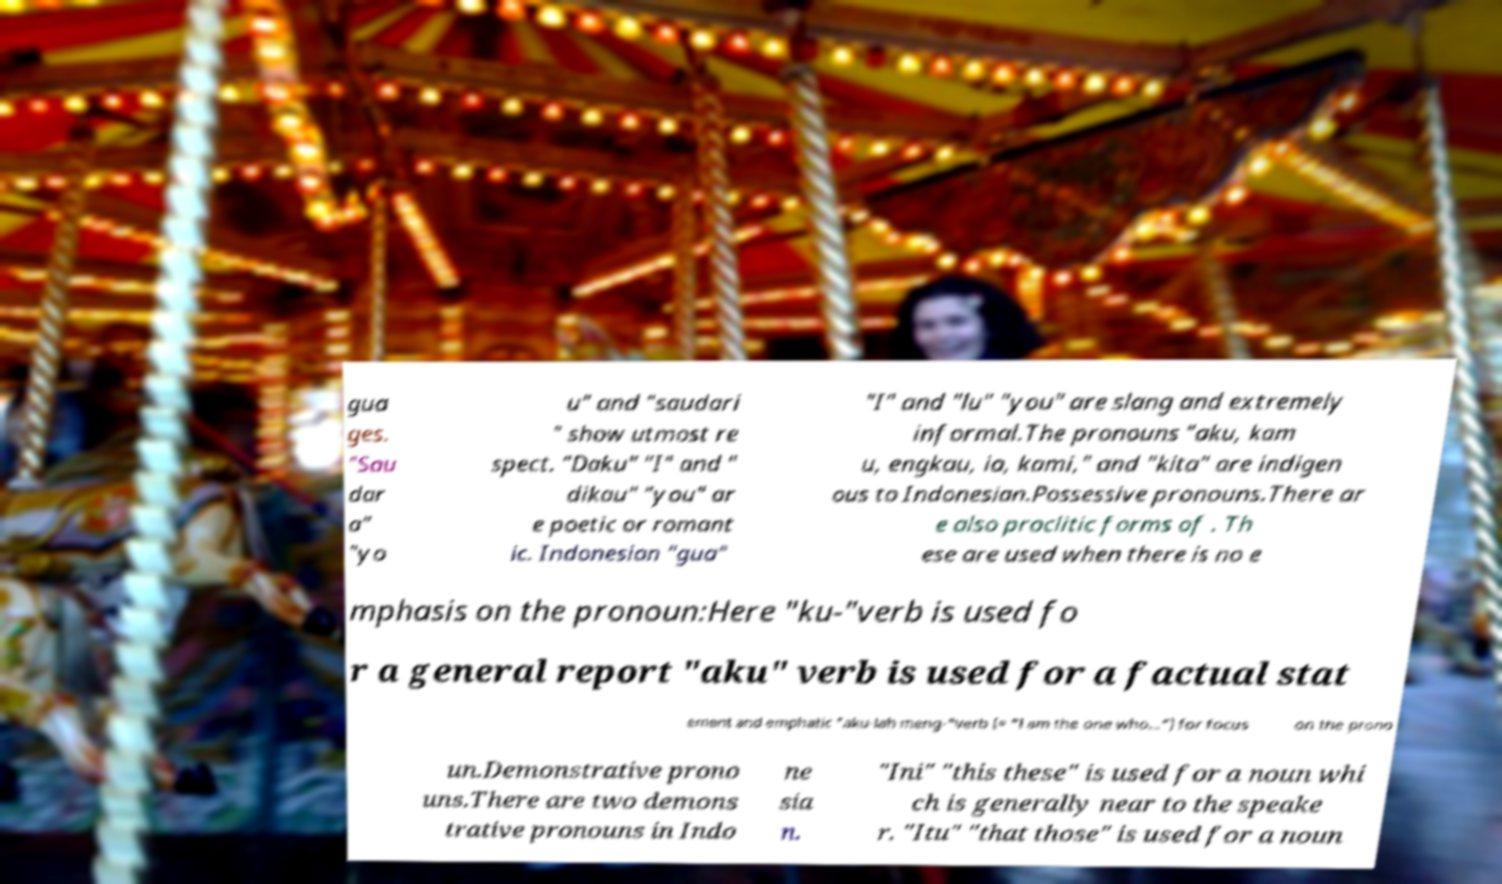There's text embedded in this image that I need extracted. Can you transcribe it verbatim? gua ges. "Sau dar a" "yo u" and "saudari " show utmost re spect. "Daku" "I" and " dikau" "you" ar e poetic or romant ic. Indonesian "gua" "I" and "lu" "you" are slang and extremely informal.The pronouns "aku, kam u, engkau, ia, kami," and "kita" are indigen ous to Indonesian.Possessive pronouns.There ar e also proclitic forms of . Th ese are used when there is no e mphasis on the pronoun:Here "ku-"verb is used fo r a general report "aku" verb is used for a factual stat ement and emphatic "aku-lah meng-"verb (≈ "I am the one who...") for focus on the prono un.Demonstrative prono uns.There are two demons trative pronouns in Indo ne sia n. "Ini" "this these" is used for a noun whi ch is generally near to the speake r. "Itu" "that those" is used for a noun 